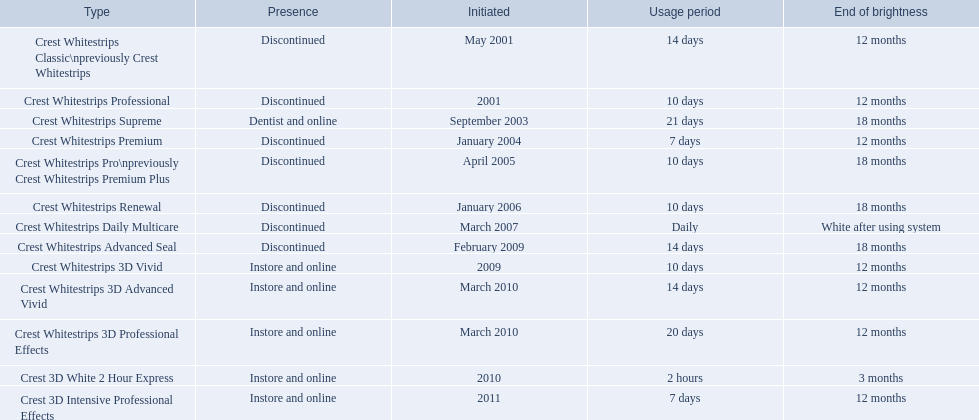What are all the models? Crest Whitestrips Classic\npreviously Crest Whitestrips, Crest Whitestrips Professional, Crest Whitestrips Supreme, Crest Whitestrips Premium, Crest Whitestrips Pro\npreviously Crest Whitestrips Premium Plus, Crest Whitestrips Renewal, Crest Whitestrips Daily Multicare, Crest Whitestrips Advanced Seal, Crest Whitestrips 3D Vivid, Crest Whitestrips 3D Advanced Vivid, Crest Whitestrips 3D Professional Effects, Crest 3D White 2 Hour Express, Crest 3D Intensive Professional Effects. Of these, for which can a ratio be calculated for 'length of use' to 'last of whiteness'? Crest Whitestrips Classic\npreviously Crest Whitestrips, Crest Whitestrips Professional, Crest Whitestrips Supreme, Crest Whitestrips Premium, Crest Whitestrips Pro\npreviously Crest Whitestrips Premium Plus, Crest Whitestrips Renewal, Crest Whitestrips Advanced Seal, Crest Whitestrips 3D Vivid, Crest Whitestrips 3D Advanced Vivid, Crest Whitestrips 3D Professional Effects, Crest 3D White 2 Hour Express, Crest 3D Intensive Professional Effects. Which has the highest ratio? Crest Whitestrips Supreme. 